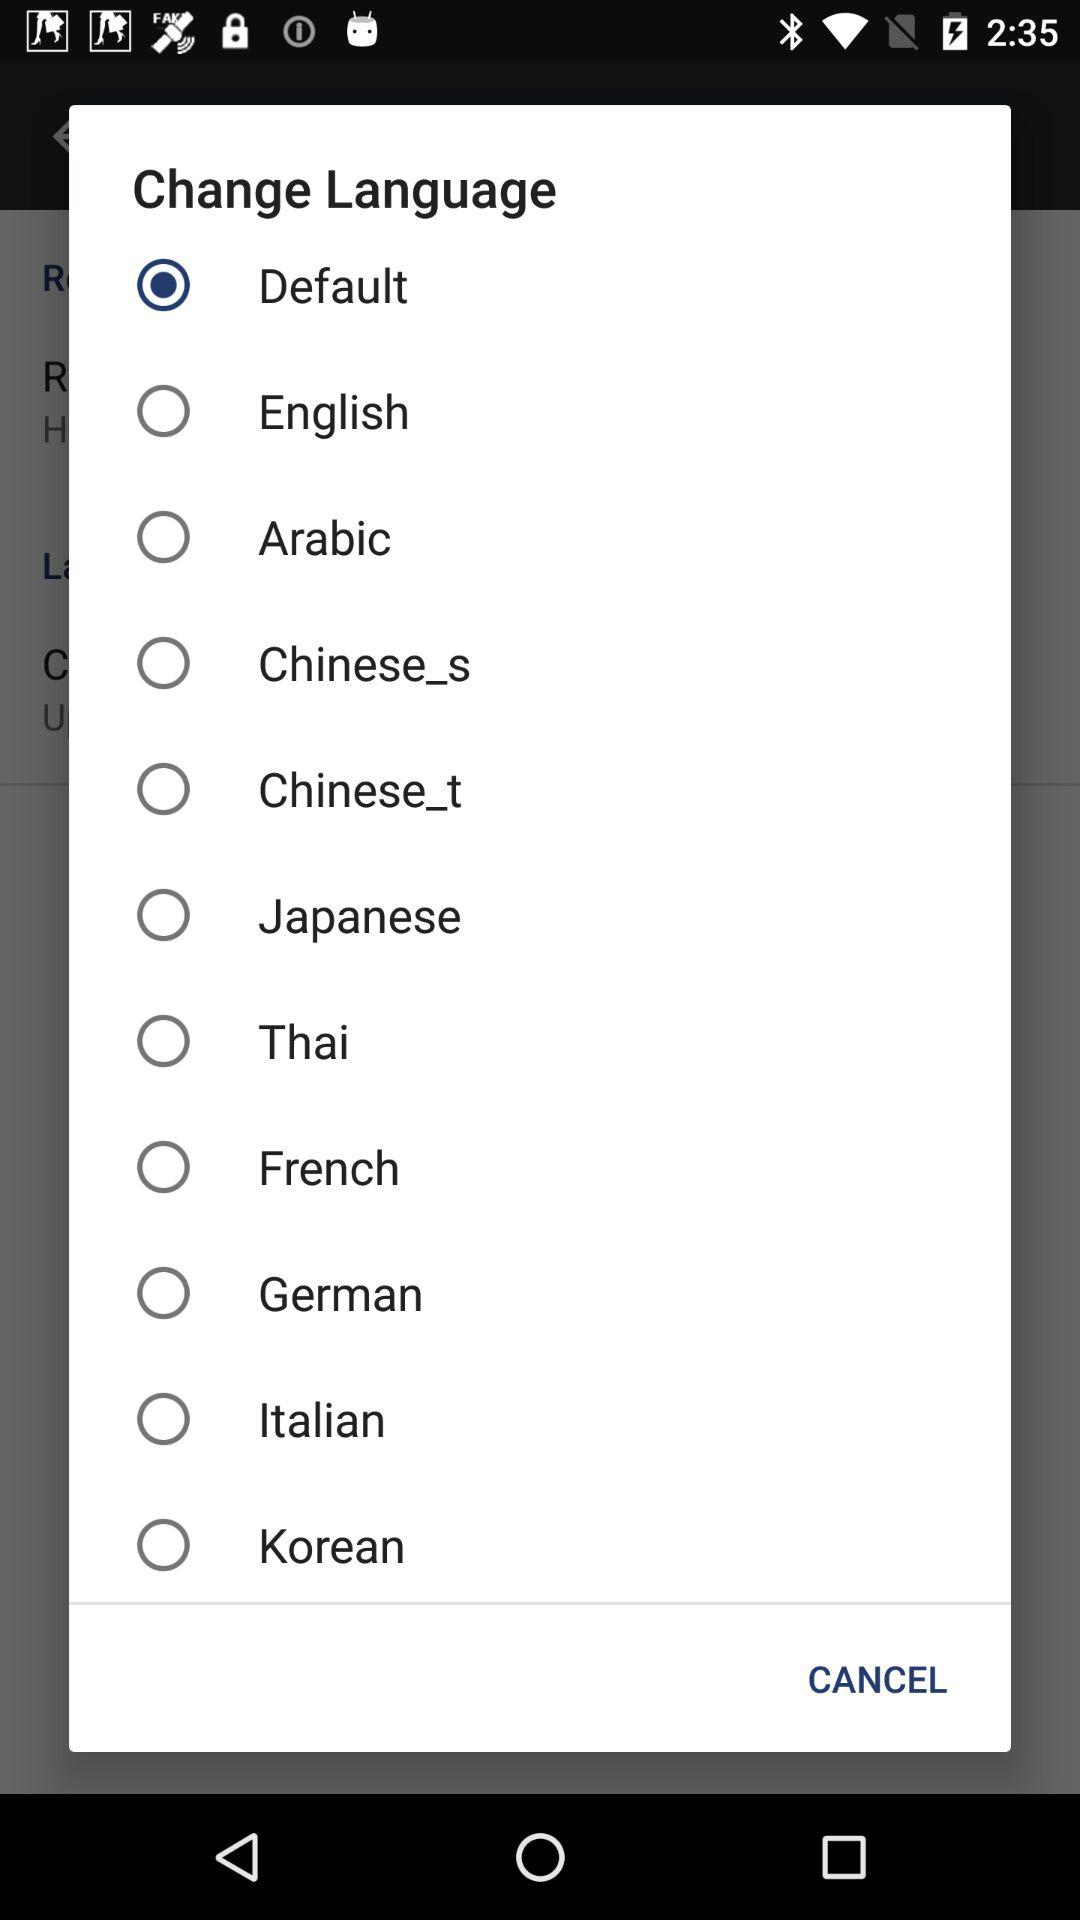What is the default language?
When the provided information is insufficient, respond with <no answer>. <no answer> 